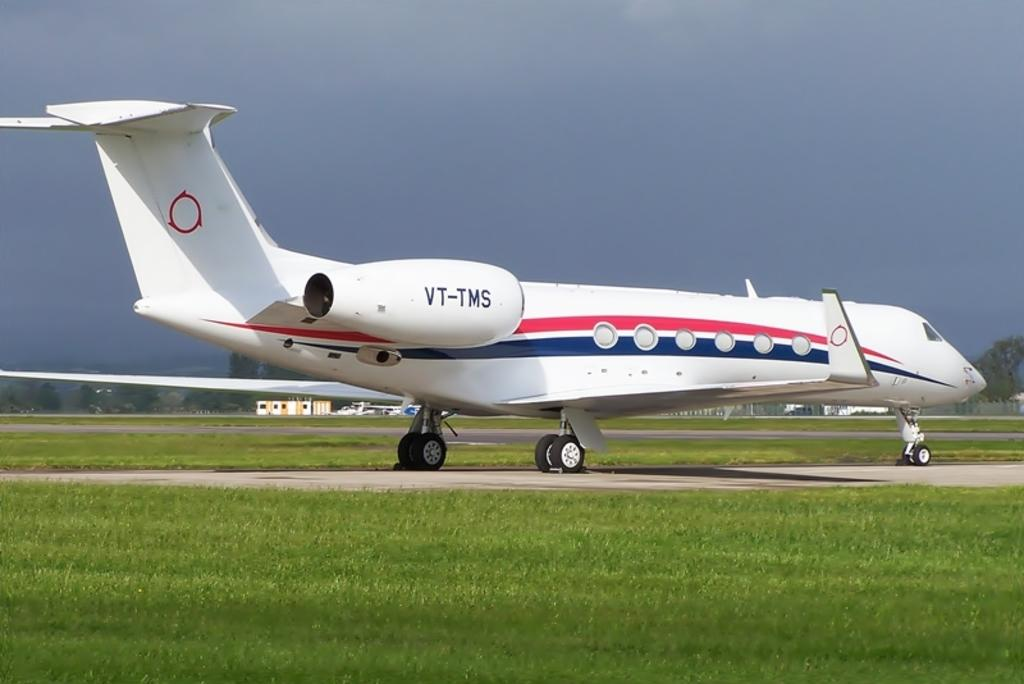<image>
Share a concise interpretation of the image provided. A small aircraft with tail designation VT-TMS at an airport 